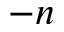Convert formula to latex. <formula><loc_0><loc_0><loc_500><loc_500>- n</formula> 